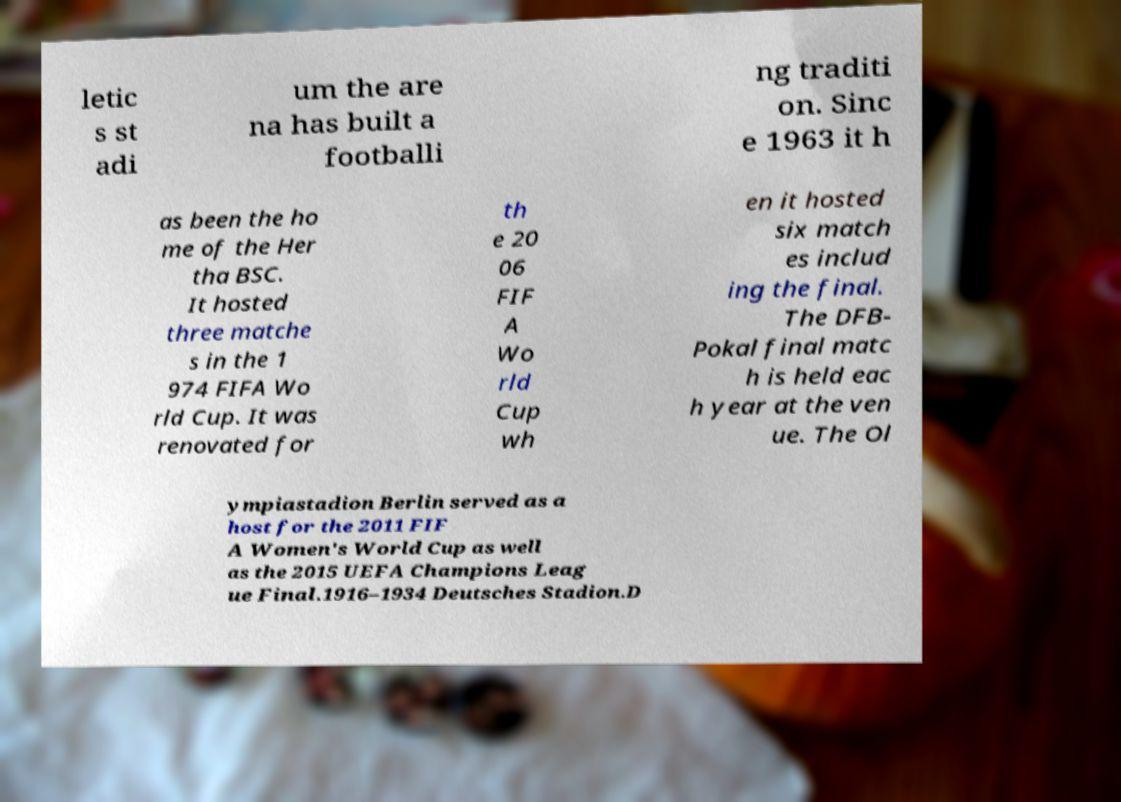Could you assist in decoding the text presented in this image and type it out clearly? letic s st adi um the are na has built a footballi ng traditi on. Sinc e 1963 it h as been the ho me of the Her tha BSC. It hosted three matche s in the 1 974 FIFA Wo rld Cup. It was renovated for th e 20 06 FIF A Wo rld Cup wh en it hosted six match es includ ing the final. The DFB- Pokal final matc h is held eac h year at the ven ue. The Ol ympiastadion Berlin served as a host for the 2011 FIF A Women's World Cup as well as the 2015 UEFA Champions Leag ue Final.1916–1934 Deutsches Stadion.D 